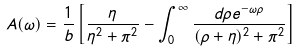Convert formula to latex. <formula><loc_0><loc_0><loc_500><loc_500>A ( \omega ) = \frac { 1 } { b } \left [ \frac { \eta } { \eta ^ { 2 } + \pi ^ { 2 } } - \int _ { 0 } ^ { \infty } \frac { d \rho e ^ { - \omega \rho } } { ( \rho + \eta ) ^ { 2 } + \pi ^ { 2 } } \right ]</formula> 